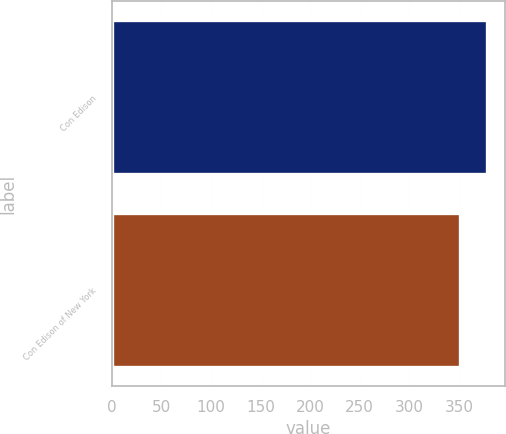Convert chart to OTSL. <chart><loc_0><loc_0><loc_500><loc_500><bar_chart><fcel>Con Edison<fcel>Con Edison of New York<nl><fcel>378<fcel>351<nl></chart> 